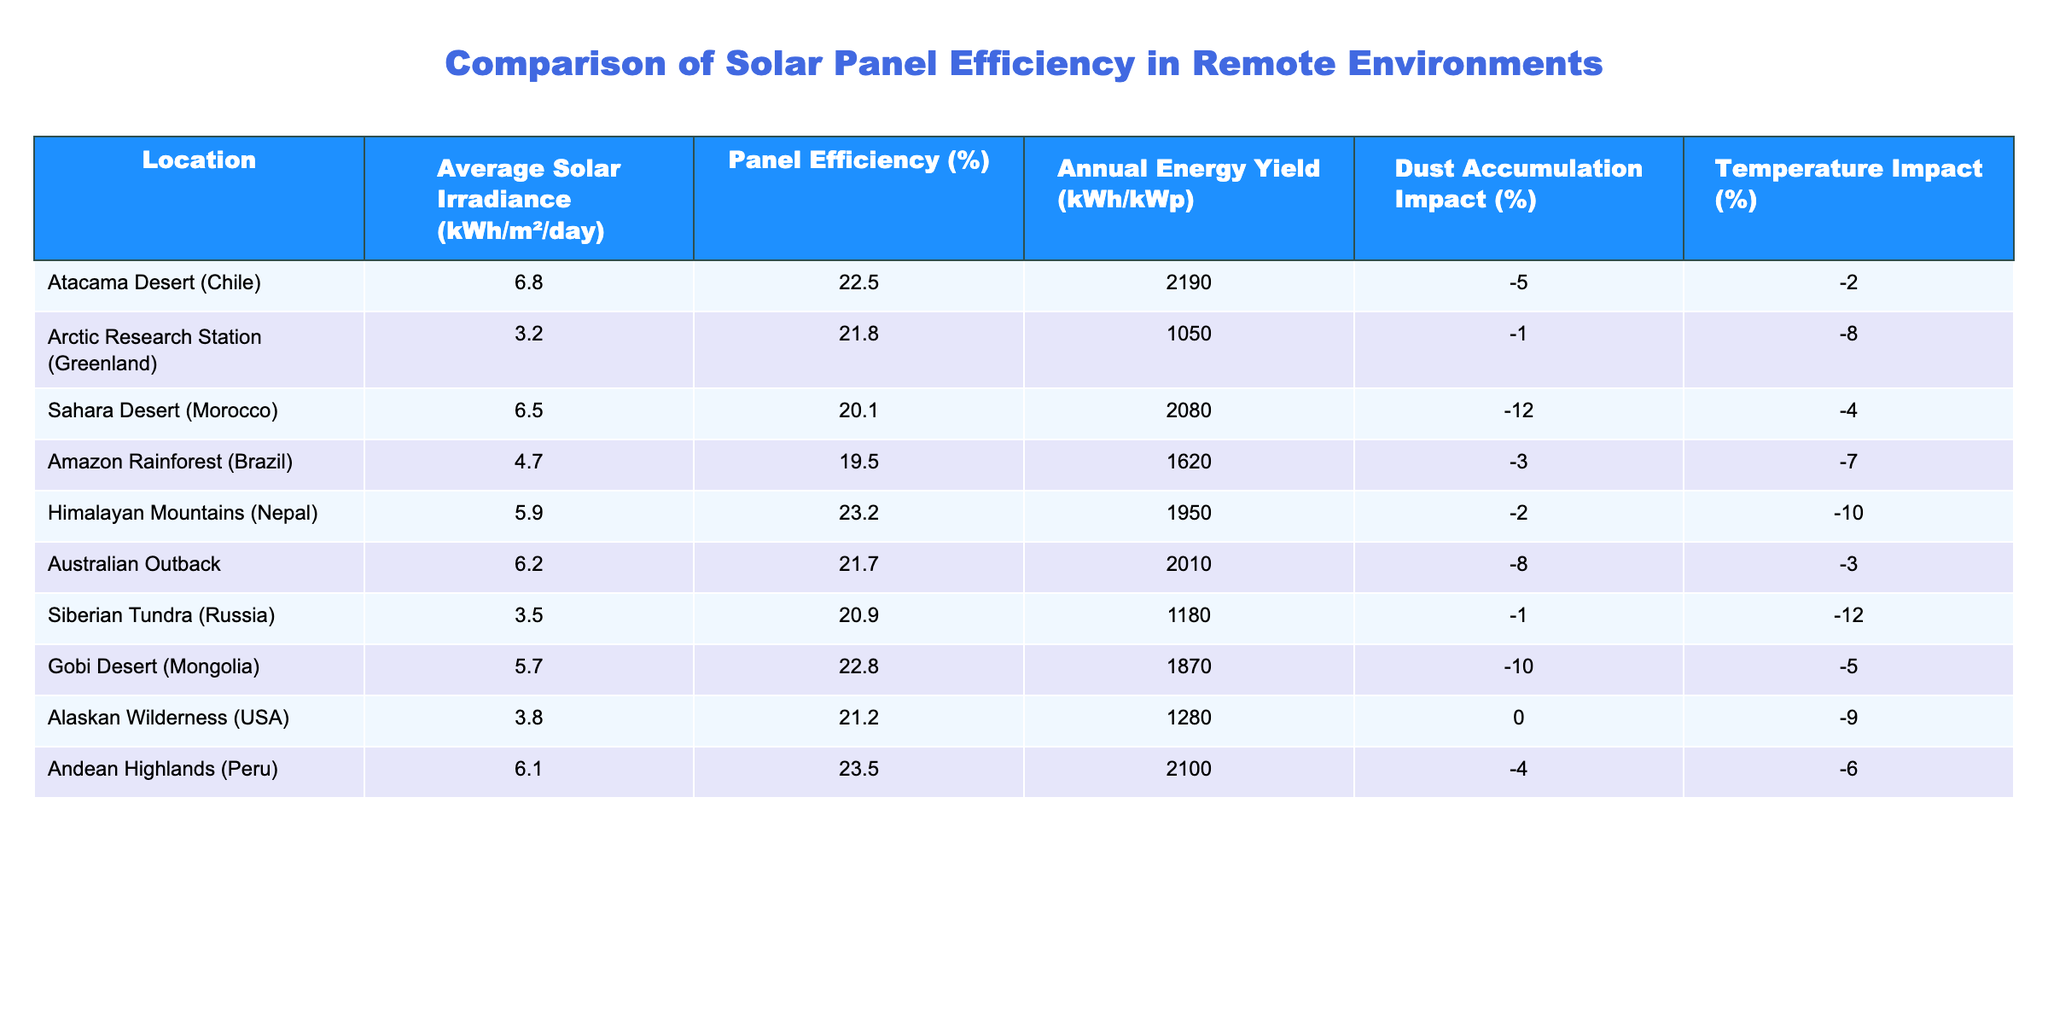What is the solar irradiance in the Atacama Desert? The table lists the Average Solar Irradiance for the Atacama Desert (Chile) as 6.8 kWh/m²/day
Answer: 6.8 kWh/m²/day Which location has the highest panel efficiency? According to the table, the Andean Highlands (Peru) has the highest panel efficiency at 23.5%.
Answer: 23.5% What is the annual energy yield for the Amazon Rainforest? The table shows that the annual energy yield for the Amazon Rainforest (Brazil) is 1620 kWh/kWp.
Answer: 1620 kWh/kWp Which environment has the least dust accumulation impact? Reviewing the dust accumulation impacts in the table, the Alaskan Wilderness (USA) has a 0% impact, which is the least.
Answer: 0% Calculate the average panel efficiency across all locations. The panel efficiencies are 22.5, 21.8, 20.1, 19.5, 23.2, 21.7, 20.9, 22.8, 21.2, and 23.5. Summing these gives 222.6, and dividing by 10 gives an average of 22.26%.
Answer: 22.3% Is there a negative temperature impact for all environments listed? By examining the temperature impacts from the table, only the Arctic Research Station has a negative temperature impact, while others have 0 or positive. Therefore, the statement is false.
Answer: No Which locations have a solar irradiance greater than 6 kWh/m²/day? From the table, the Atacama Desert (6.8), Sahara Desert (6.5), and Australian Outback (6.2) all have a solar irradiance greater than 6.
Answer: Atacama Desert, Sahara Desert, Australian Outback Compare the annual energy yield of the Arctic Research Station and Siberian Tundra. The Arctic Research Station has an annual energy yield of 1050 kWh/kWp, while the Siberian Tundra has 1180 kWh/kWp, making the latter higher by a difference of 130 kWh/kWp.
Answer: 130 kWh/kWp What is the total impact of dust and temperature accumulation at the Gobi Desert? The Gobi Desert has a dust accumulation impact of -10% and a temperature impact of -5%. Summing these gives a total impact of -15%.
Answer: -15% Identify the location with the least annual energy yield. The Arctic Research Station has the lowest annual energy yield at 1050 kWh/kWp according to the table.
Answer: 1050 kWh/kWp 